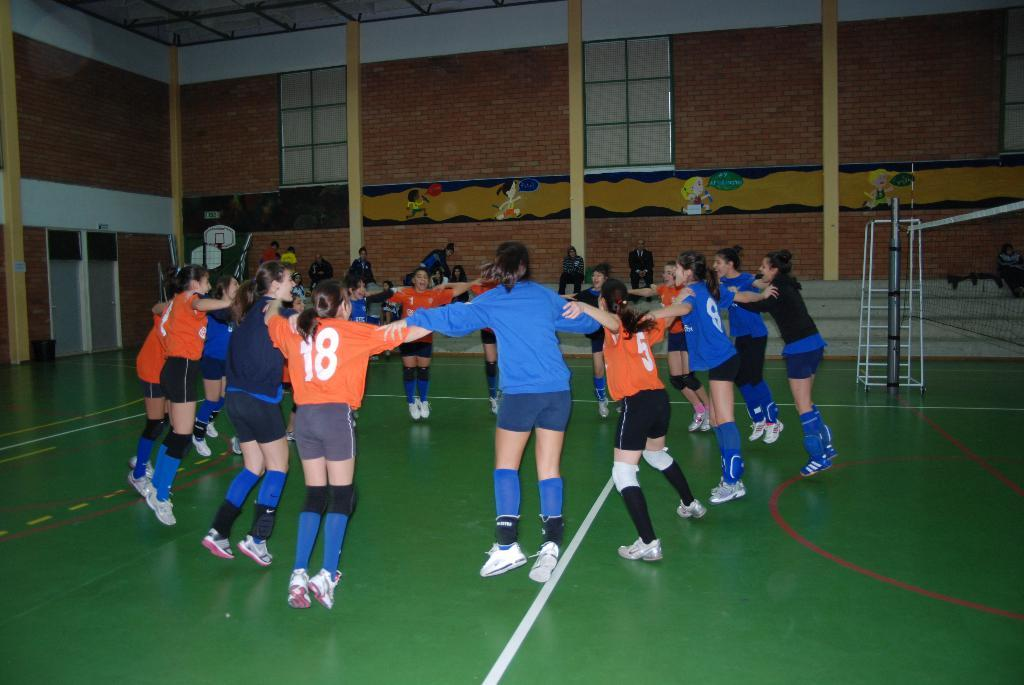<image>
Present a compact description of the photo's key features. A circle of girls jumping around and one of the girls has the number 18 on her back. 